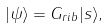<formula> <loc_0><loc_0><loc_500><loc_500>| \psi \rangle = G _ { r i b } | s \rangle ,</formula> 